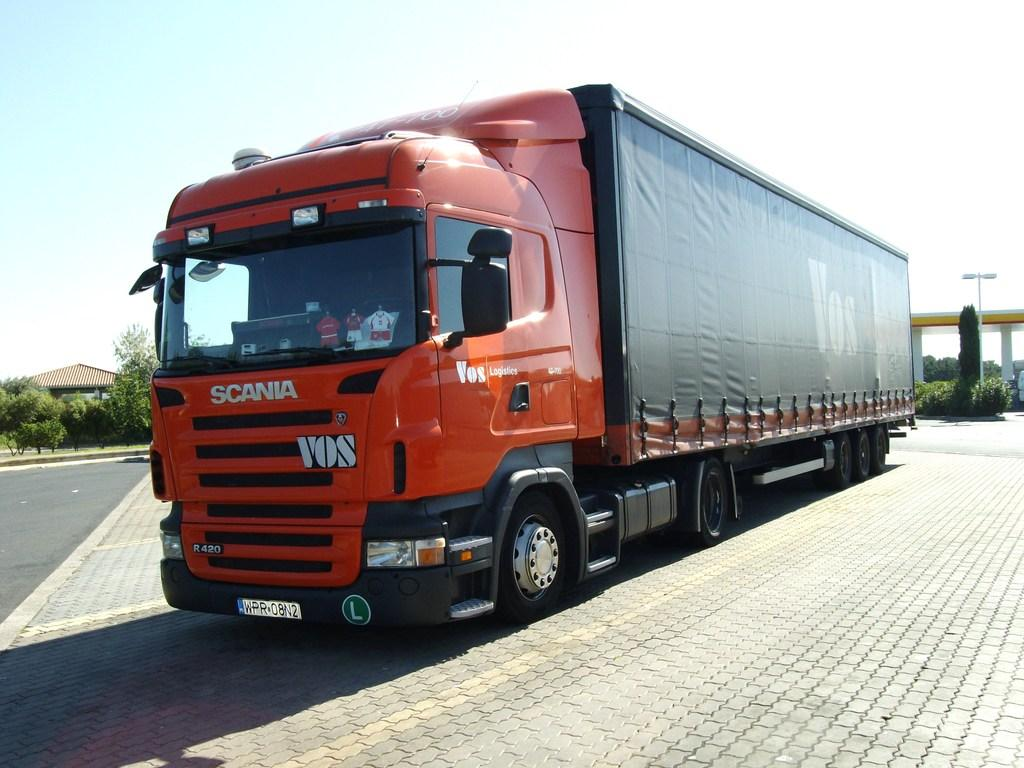What is the main subject of the image? There is a vehicle on the road in the image. What structures can be seen in the background of the image? There is a house, a shed, and a pole in the background of the image. What type of vegetation is visible in the background of the image? There are trees in the background of the image. What part of the natural environment is visible in the image? The sky is visible in the background of the image. How many docks are visible in the image? There are no docks present in the image. What type of adjustment is being made to the vehicle in the image? There is no adjustment being made to the vehicle in the image; it is simply parked on the road. 